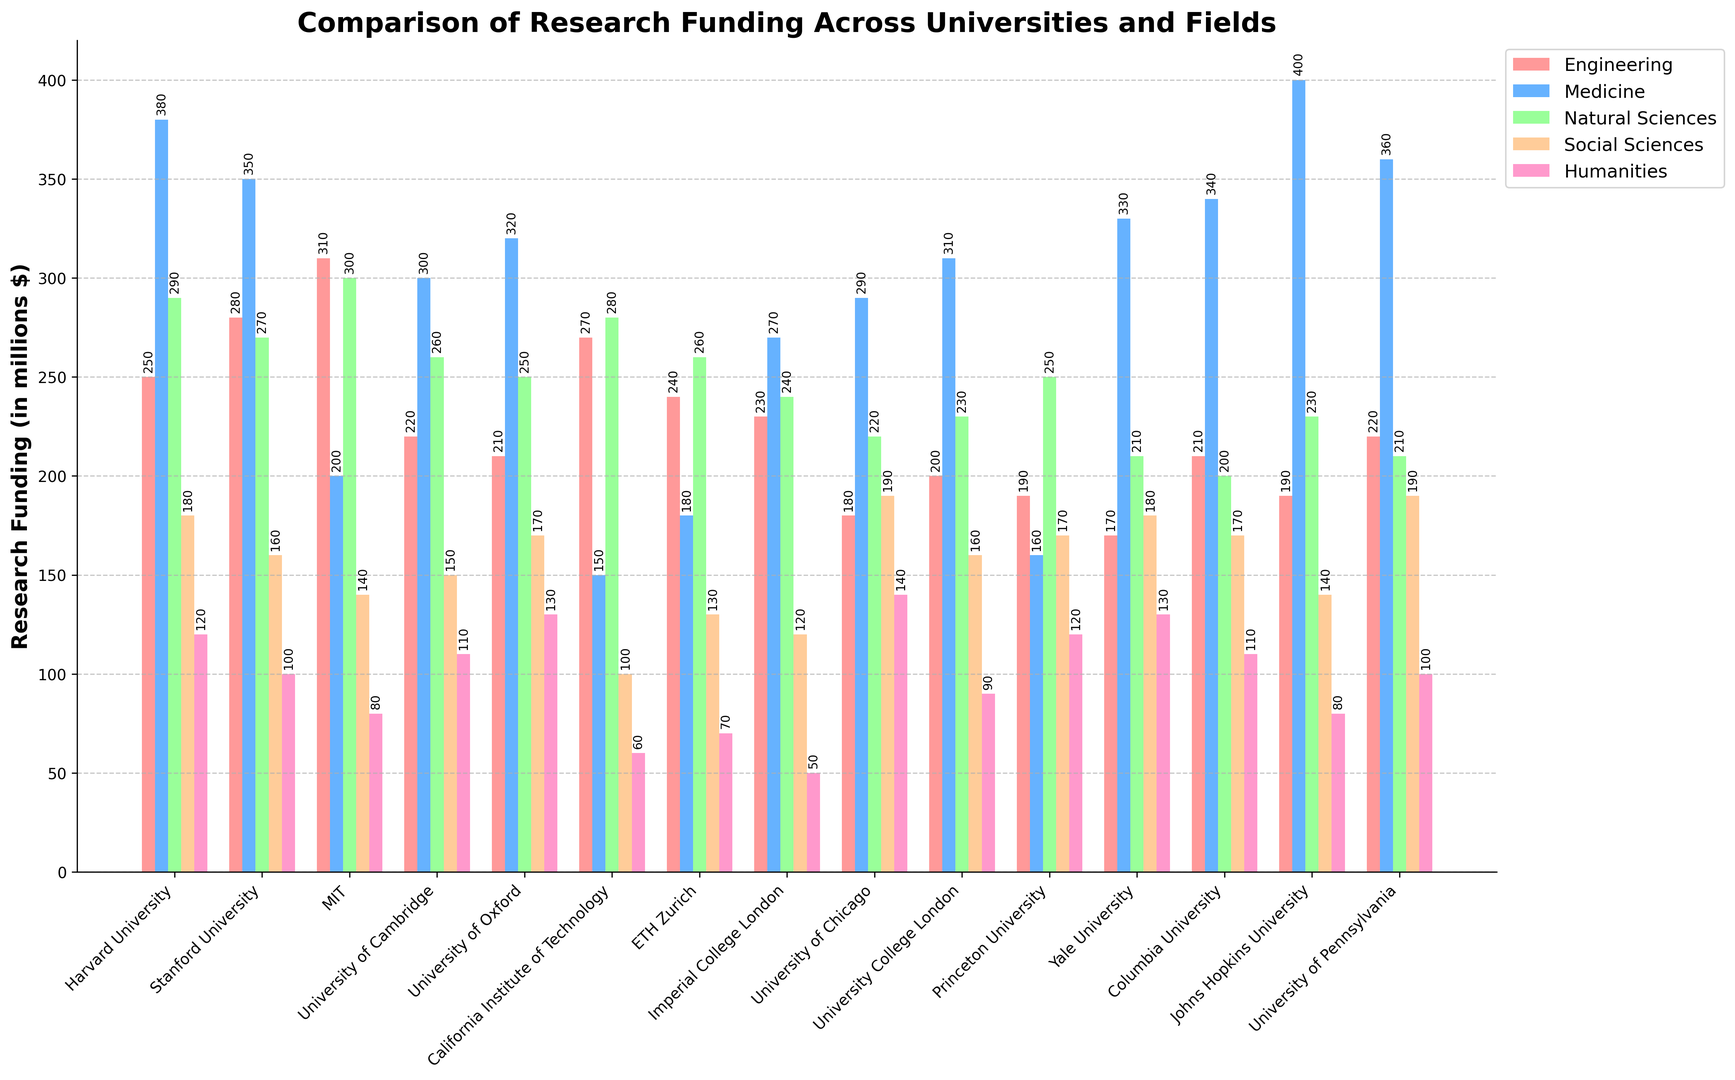How does the research funding for Engineering compare between MIT and Stanford University? To compare the research funding for Engineering between MIT and Stanford University, look at the corresponding bars for the Engineering field. MIT has a funding of $310 million while Stanford University has $280 million.
Answer: MIT has $30 million more Which university has the highest funding in Medicine, and what is the amount? Find the tallest bar in the Medicine category, which represents the highest funding. Johns Hopkins University has the highest funding in Medicine with $400 million.
Answer: Johns Hopkins University with $400 million What is the total research funding for Natural Sciences at Harvard University and Princeton University combined? Sum the values of research funding for Natural Sciences at Harvard University and Princeton University. Harvard University has $290 million and Princeton University has $250 million. The combined total is $290 million + $250 million = $540 million.
Answer: $540 million Which field of study receives the least funding at California Institute of Technology, and what is the amount? Look at the bars for California Institute of Technology and identify the shortest one, which is Humanities. The funding amount for Humanities is $60 million.
Answer: Humanities with $60 million Compare the research funding for Social Sciences at University of Chicago with University of Pennsylvania. Which one is higher, and by how much? Compare the height of the bars for Social Sciences at both universities. University of Chicago has $190 million, and University of Pennsylvania has $190 million. They are equal in funding.
Answer: Equal with both at $190 million What is the average funding received by University College London across all fields of study? Add the research funding for all fields at University College London, then divide by the number of fields. The total funding is $200 million + $310 million + $230 million + $160 million + $90 million = $990 million. With 5 fields, the average funding is $990 million / 5 = $198 million.
Answer: $198 million How much more funding does ETH Zurich receive for Engineering compared to the Humanities? Subtract the funding for Humanities from the funding for Engineering at ETH Zurich. ETH Zurich receives $240 million for Engineering and $70 million for Humanities, so $240 million - $70 million = $170 million.
Answer: $170 million more Which university has the lowest funding in Natural Sciences, and what is the amount? Identify the shortest bar in the Natural Sciences category. Columbia University has the lowest funding in Natural Sciences with $200 million.
Answer: Columbia University with $200 million What is the difference in Medicine funding between Harvard University and Yale University? Subtract the funding for Medicine at Yale University from that at Harvard University. Harvard University has $380 million and Yale University has $330 million. The difference is $380 million - $330 million = $50 million.
Answer: $50 million Rank the top three universities by their funding in Engineering. Look at the heights of the bars for Engineering and determine the top three. MIT ($310 million), Stanford University ($280 million), and California Institute of Technology ($270 million) are the top three.
Answer: 1. MIT, 2. Stanford University, 3. California Institute of Technology 